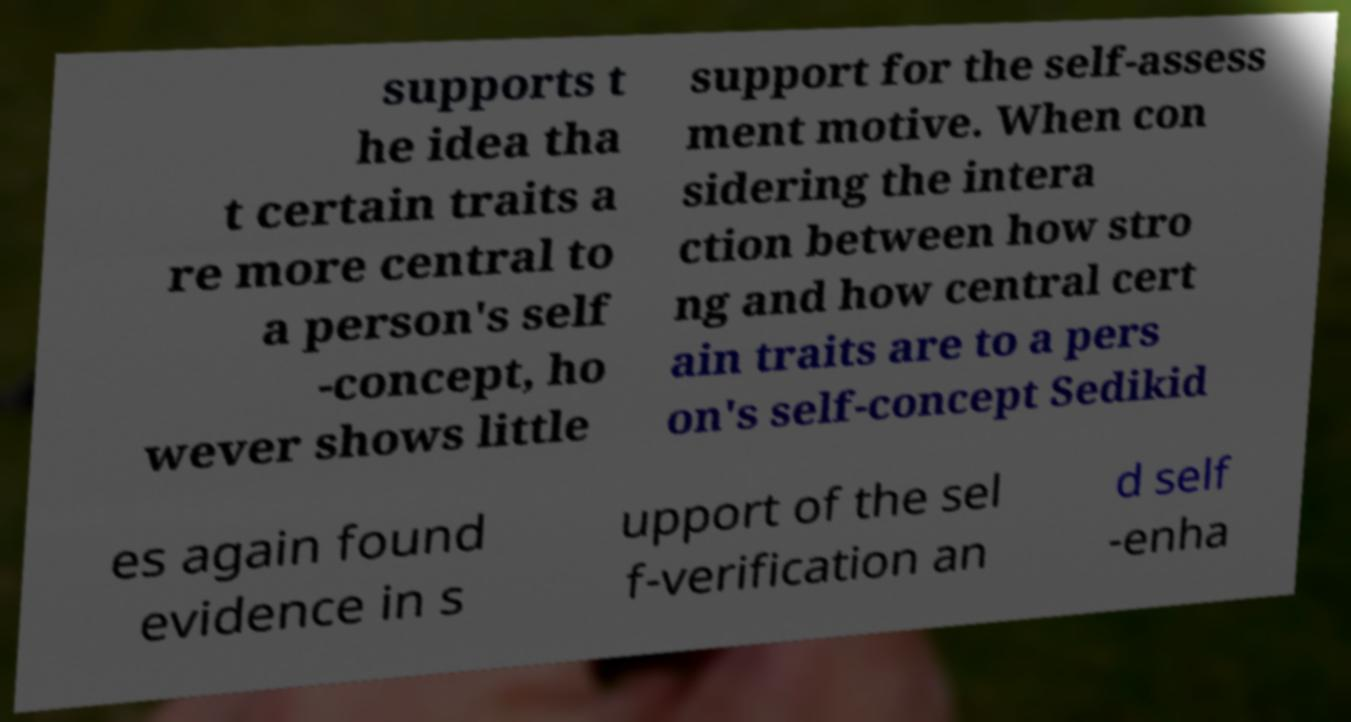Can you accurately transcribe the text from the provided image for me? supports t he idea tha t certain traits a re more central to a person's self -concept, ho wever shows little support for the self-assess ment motive. When con sidering the intera ction between how stro ng and how central cert ain traits are to a pers on's self-concept Sedikid es again found evidence in s upport of the sel f-verification an d self -enha 